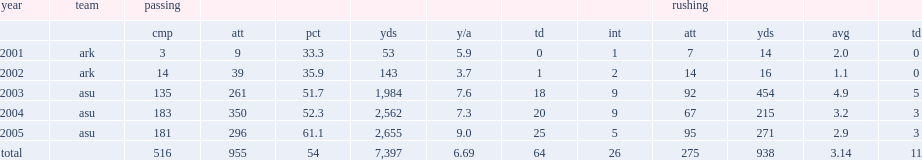How many passing yards did tarvaris jackson get in 2005? 2655.0. 